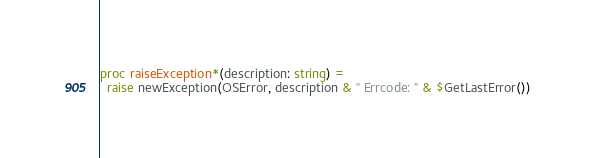<code> <loc_0><loc_0><loc_500><loc_500><_Nim_>proc raiseException*(description: string) = 
  raise newException(OSError, description & " Errcode: " & $GetLastError())</code> 